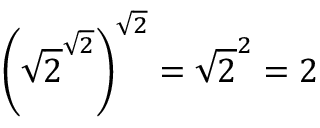<formula> <loc_0><loc_0><loc_500><loc_500>\left ( { \sqrt { 2 } } ^ { \sqrt { 2 } } \right ) ^ { \sqrt { 2 } } = { \sqrt { 2 } } ^ { 2 } = 2</formula> 